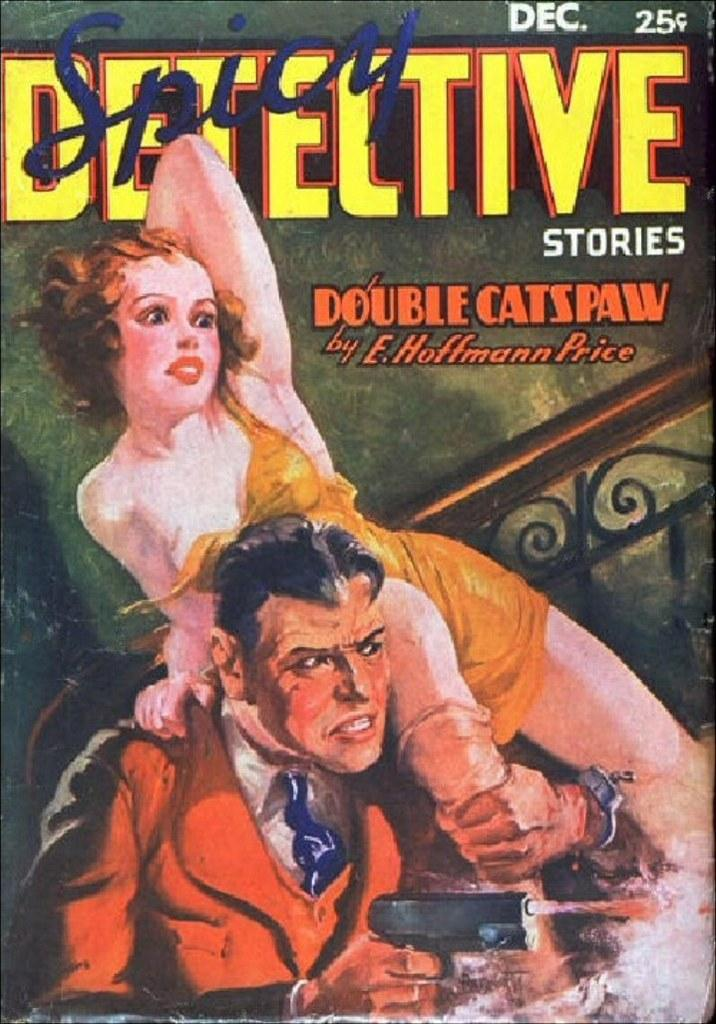<image>
Write a terse but informative summary of the picture. A book cover with spicy detective stories written by E. Hoffmann Price. 